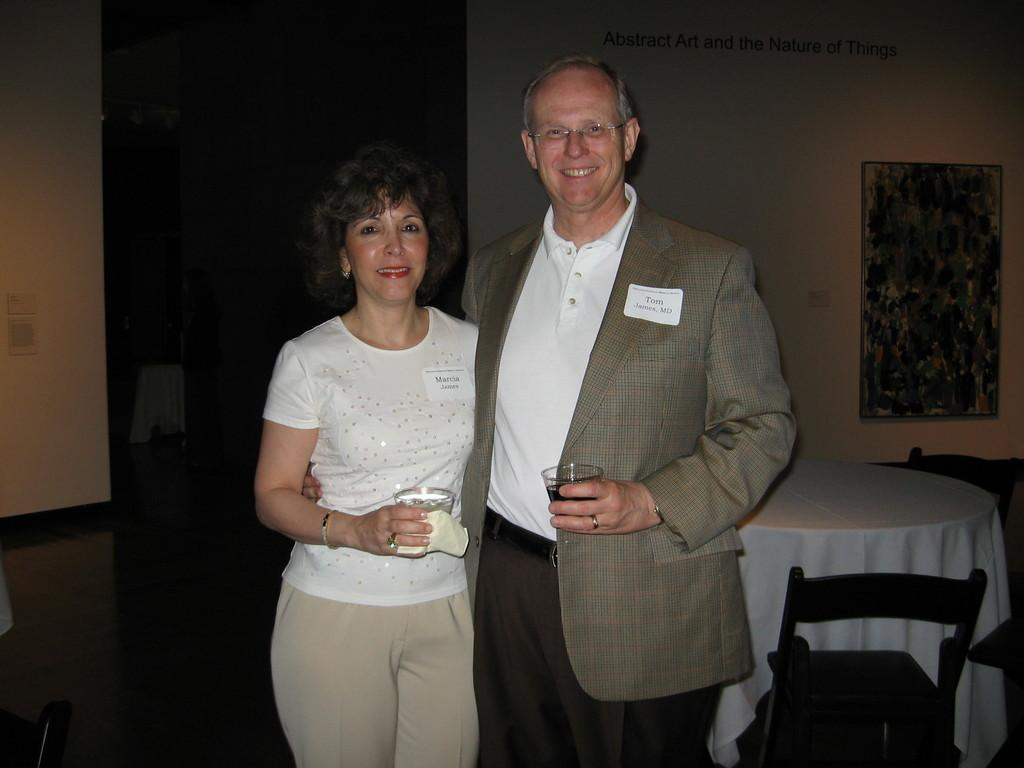How many people are in the image? There are two people in the image: a man and a woman. What are the man and woman holding in their hands? The man and woman are holding glasses in their hands. What can be seen on the wall in the image? There is a photo frame on the wall. What type of furniture is present in the image? There is a table and chairs in the image. What type of canvas is visible in the image? There is no canvas present in the image. How deep is the hole in the image? There is no hole present in the image. 